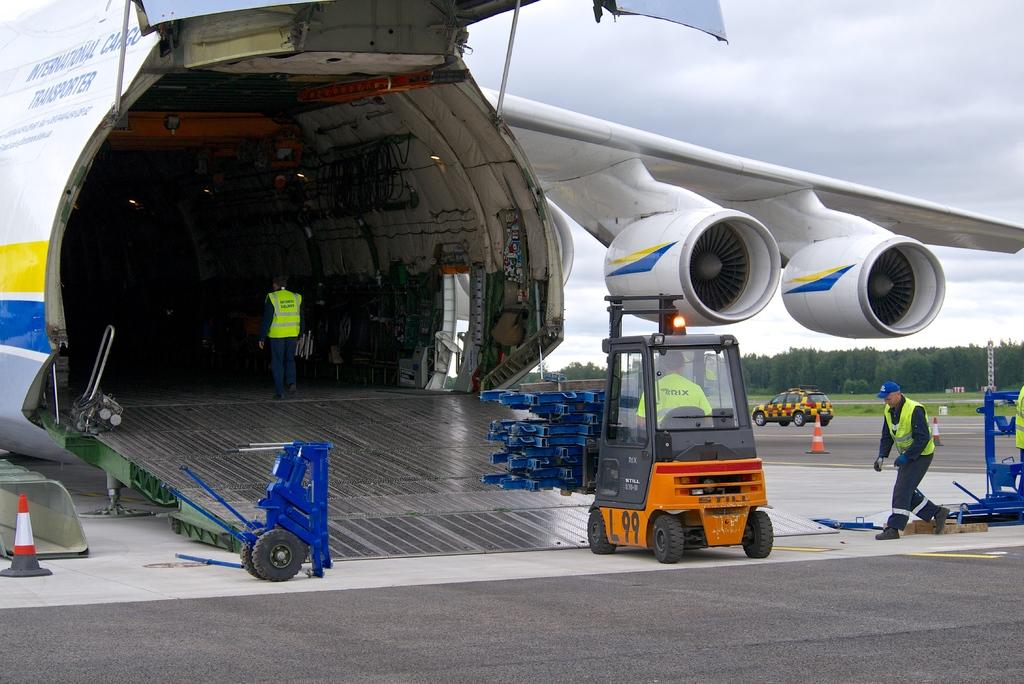<image>
Provide a brief description of the given image. A forklift is driving into the rear of a large International Cargo Transporter. 